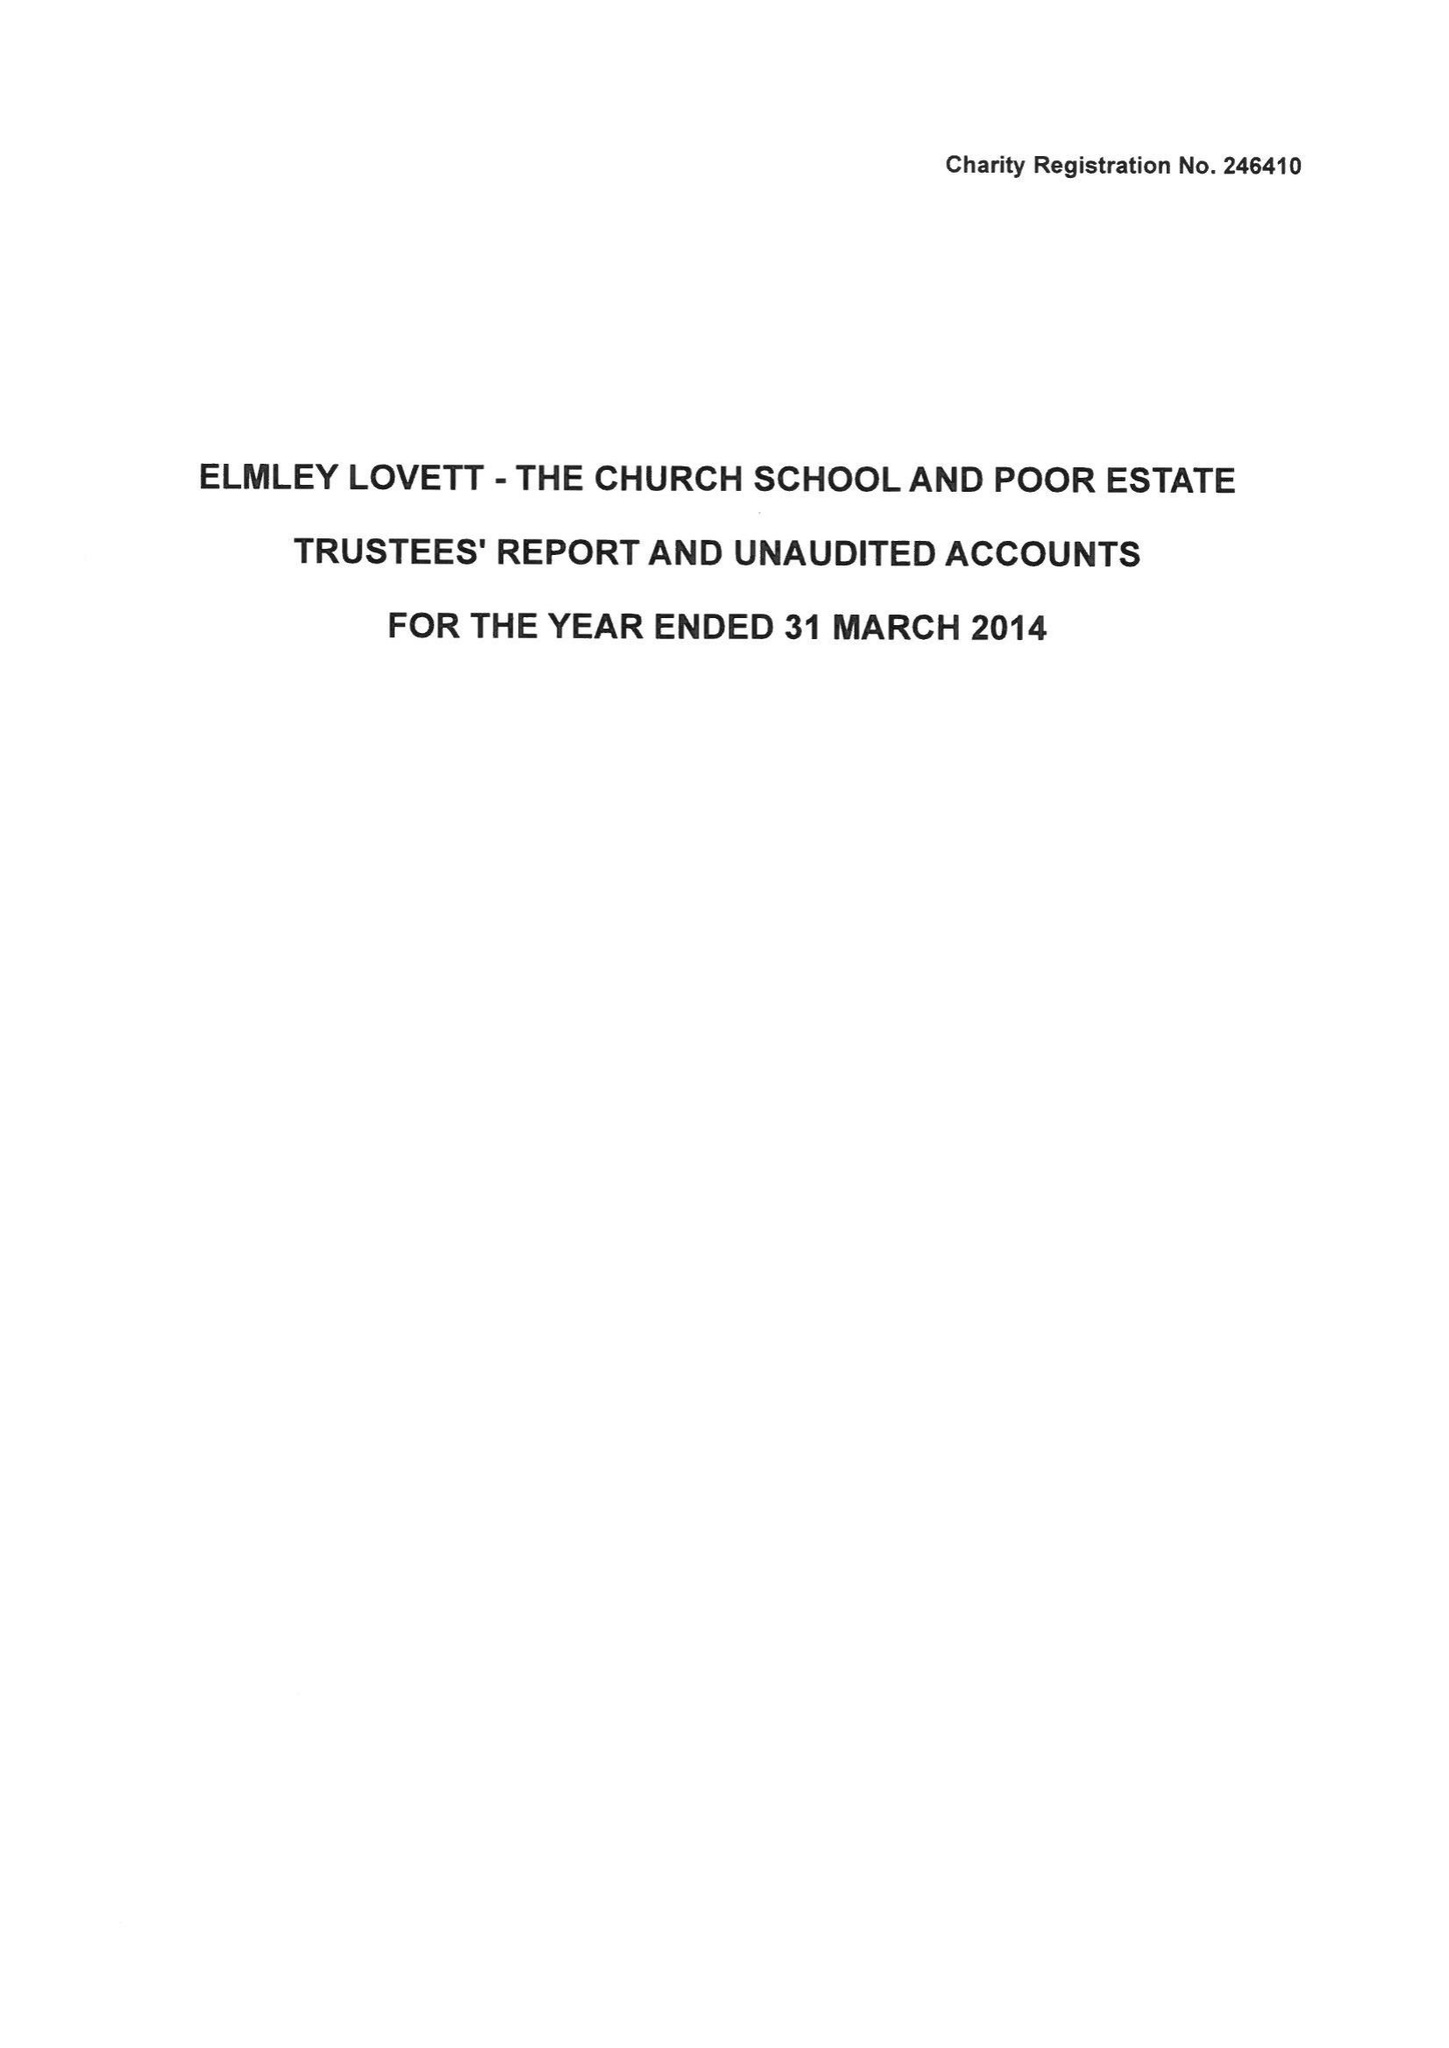What is the value for the report_date?
Answer the question using a single word or phrase. 2014-03-31 